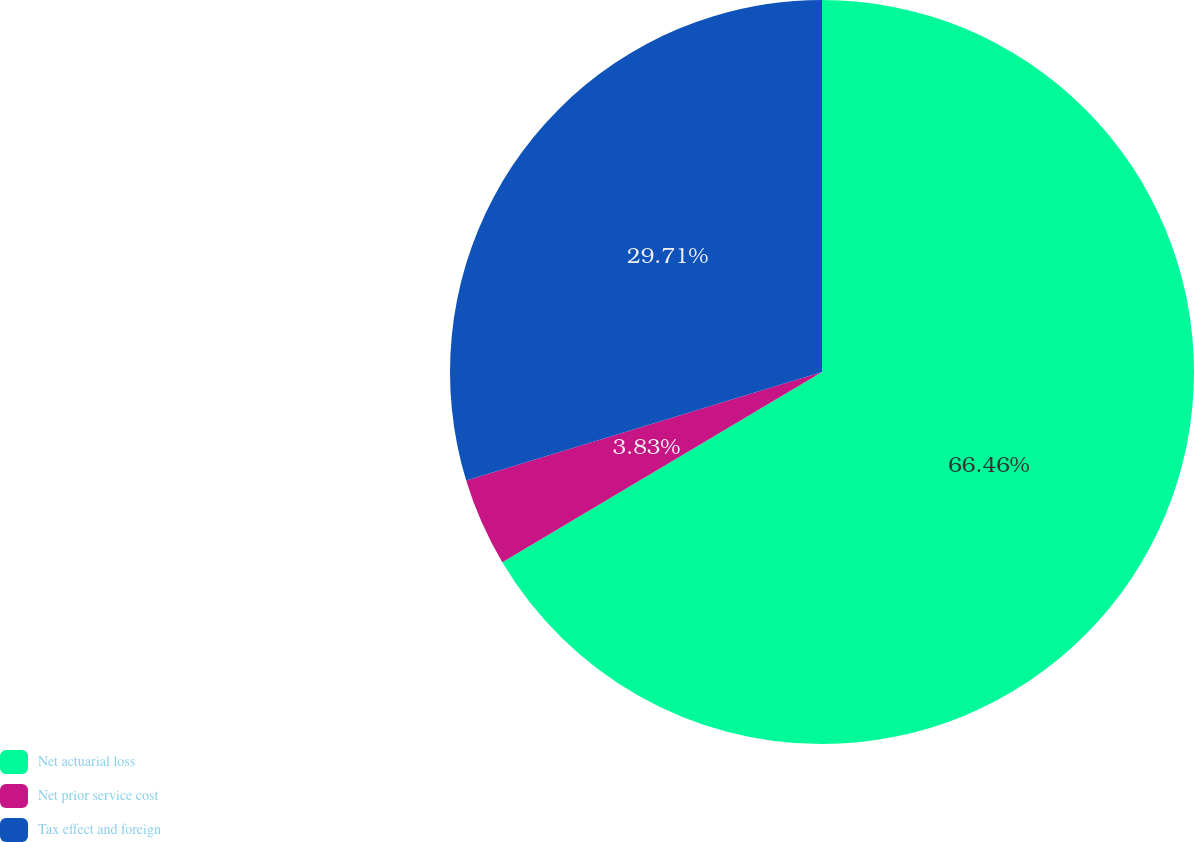<chart> <loc_0><loc_0><loc_500><loc_500><pie_chart><fcel>Net actuarial loss<fcel>Net prior service cost<fcel>Tax effect and foreign<nl><fcel>66.45%<fcel>3.83%<fcel>29.71%<nl></chart> 